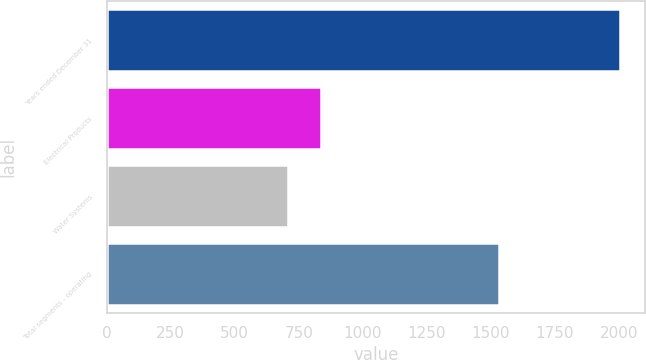Convert chart. <chart><loc_0><loc_0><loc_500><loc_500><bar_chart><fcel>Years ended December 31<fcel>Electrical Products<fcel>Water Systems<fcel>Total segments - operating<nl><fcel>2003<fcel>835.79<fcel>706.1<fcel>1530.7<nl></chart> 